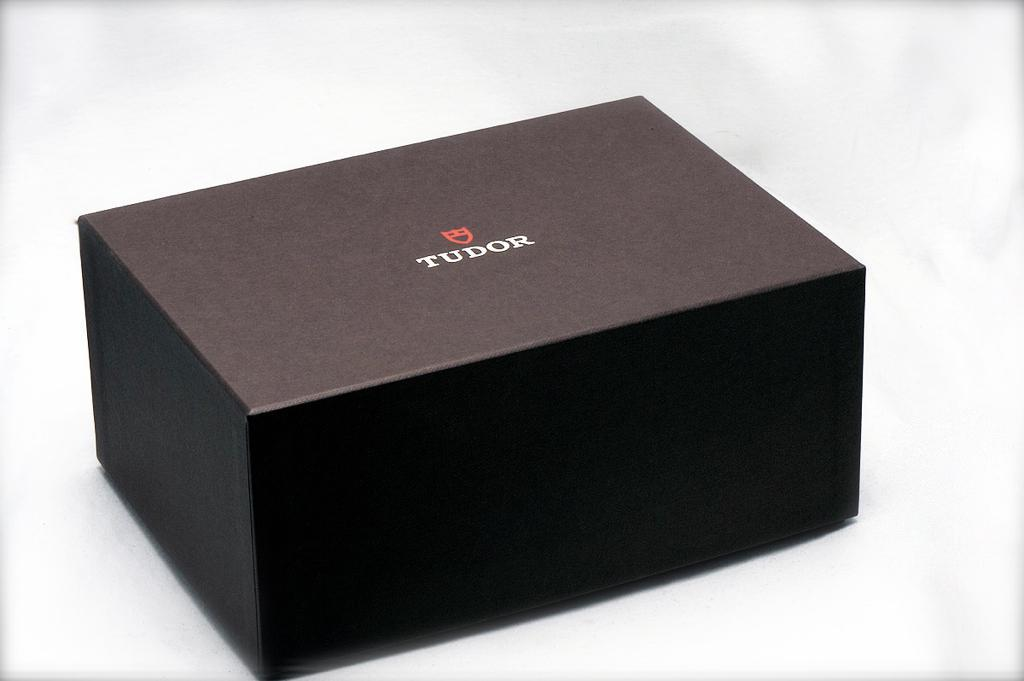<image>
Offer a succinct explanation of the picture presented. A plain black Tudor box is sitting on a white surface 